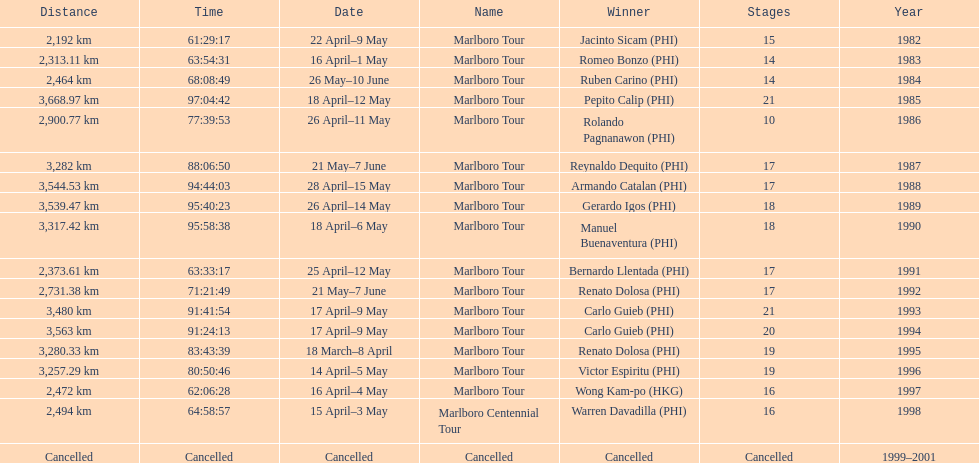What was the total number of winners before the tour was canceled? 17. 